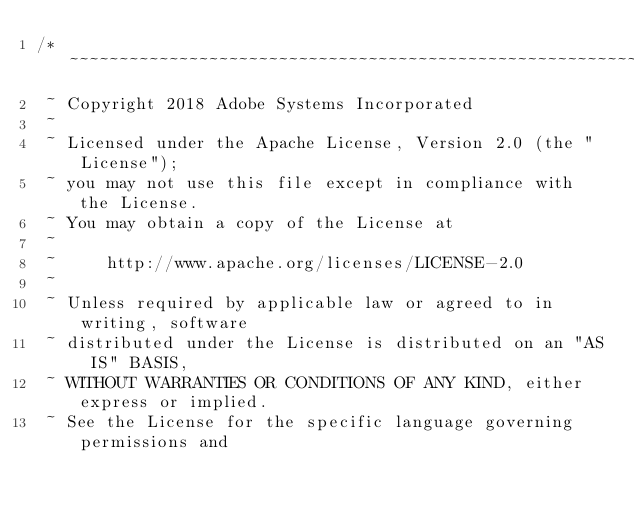Convert code to text. <code><loc_0><loc_0><loc_500><loc_500><_CSS_>/*~~~~~~~~~~~~~~~~~~~~~~~~~~~~~~~~~~~~~~~~~~~~~~~~~~~~~~~~~~~~~~~~~~~~~~~~~~~~~~
 ~ Copyright 2018 Adobe Systems Incorporated
 ~
 ~ Licensed under the Apache License, Version 2.0 (the "License");
 ~ you may not use this file except in compliance with the License.
 ~ You may obtain a copy of the License at
 ~
 ~     http://www.apache.org/licenses/LICENSE-2.0
 ~
 ~ Unless required by applicable law or agreed to in writing, software
 ~ distributed under the License is distributed on an "AS IS" BASIS,
 ~ WITHOUT WARRANTIES OR CONDITIONS OF ANY KIND, either express or implied.
 ~ See the License for the specific language governing permissions and</code> 